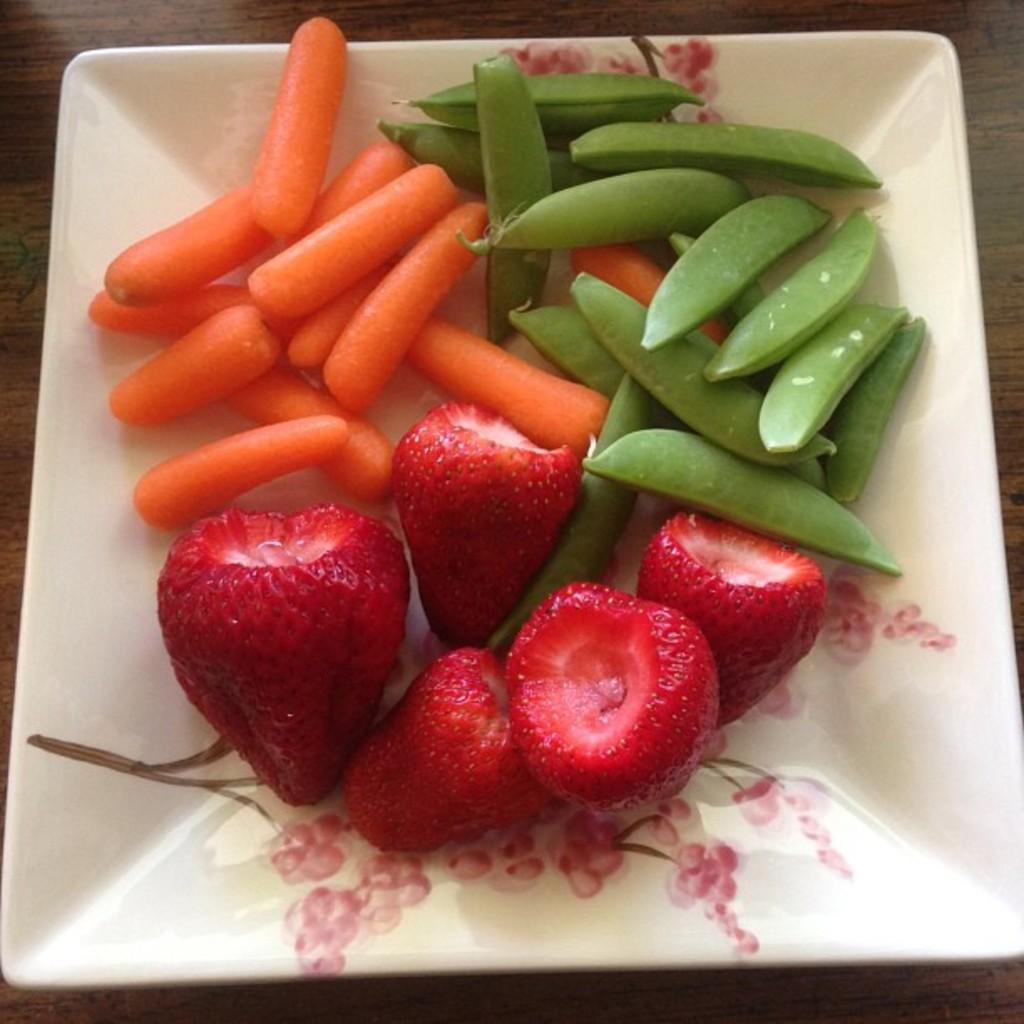What type of fruit can be seen in the image? There are strawberries in the image. What type of vegetable can also be seen in the image? There are carrots in the image. What category of food do both strawberries and carrots belong to? Both strawberries and carrots are vegetables in the image. What is used to hold the vegetables in the image? There is a plate in the image. What surface is the plate placed on in the image? The wooden surface is present in the image. What type of steam can be seen rising from the vegetables in the image? There is no steam present in the image; it is a still image of vegetables on a plate. 